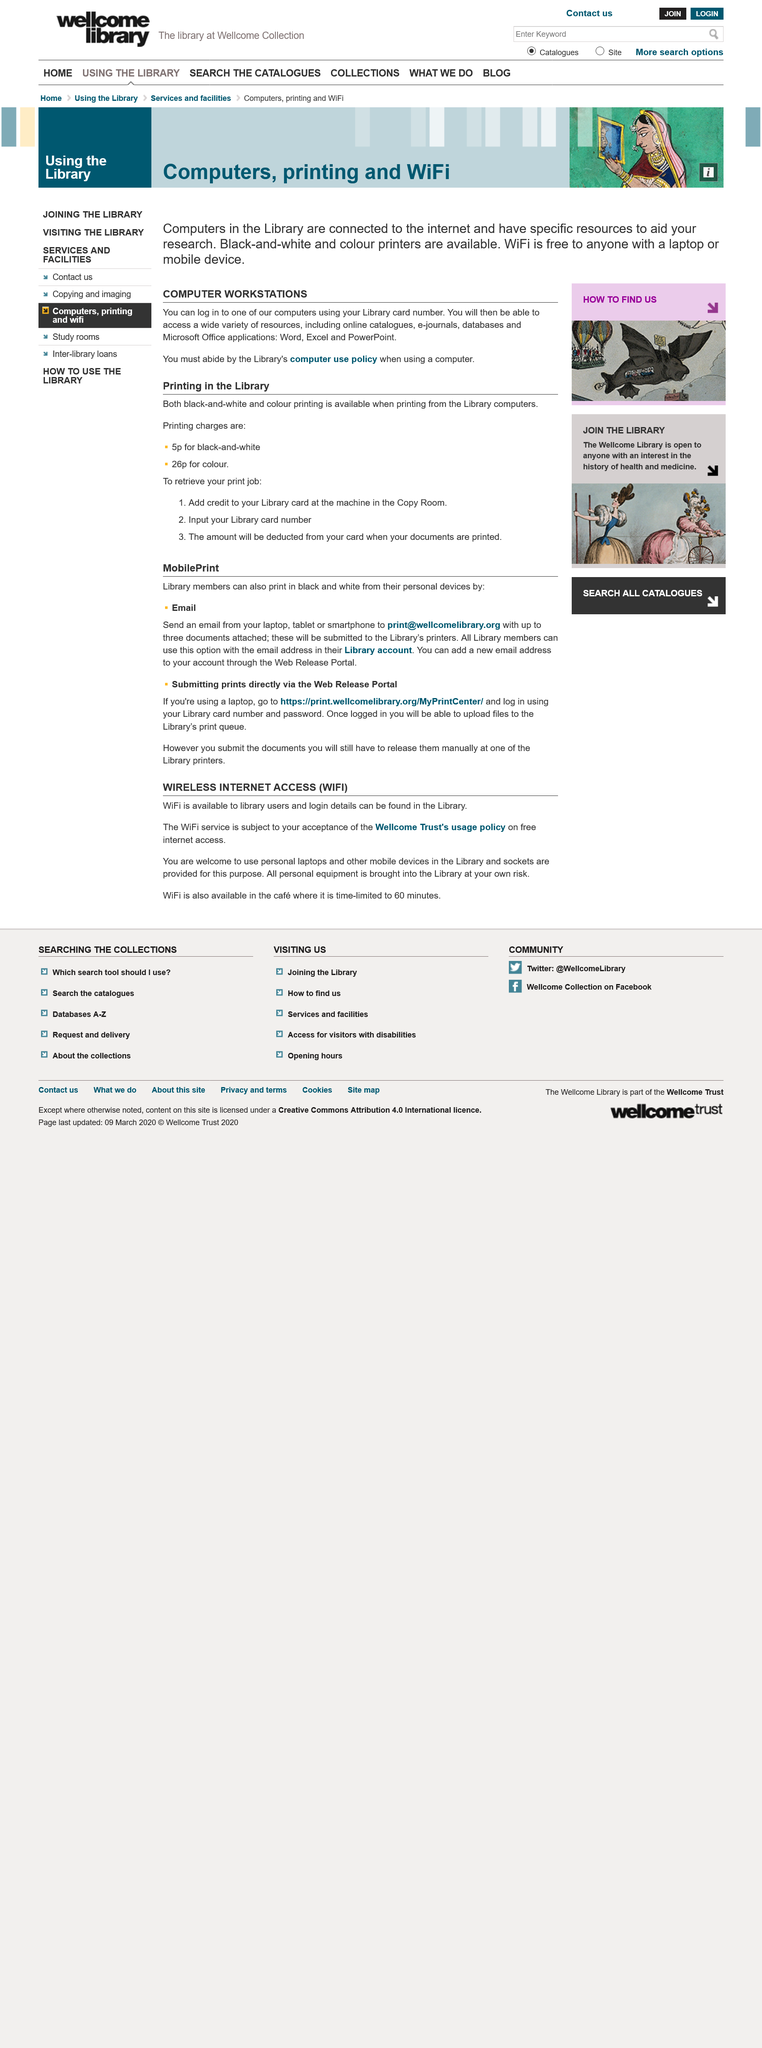Identify some key points in this picture. The internet is free at the library as long as the user accepts the usage policy, which means that the internet is indeed free. Yes, black and white printing is available. It is not the responsibility of the library to protect personal equipment brought into the library, and all equipment is brought in at the owner's risk. Yes, color printing is available. To access a Library computer, please enter your Library card number and corresponding password. 